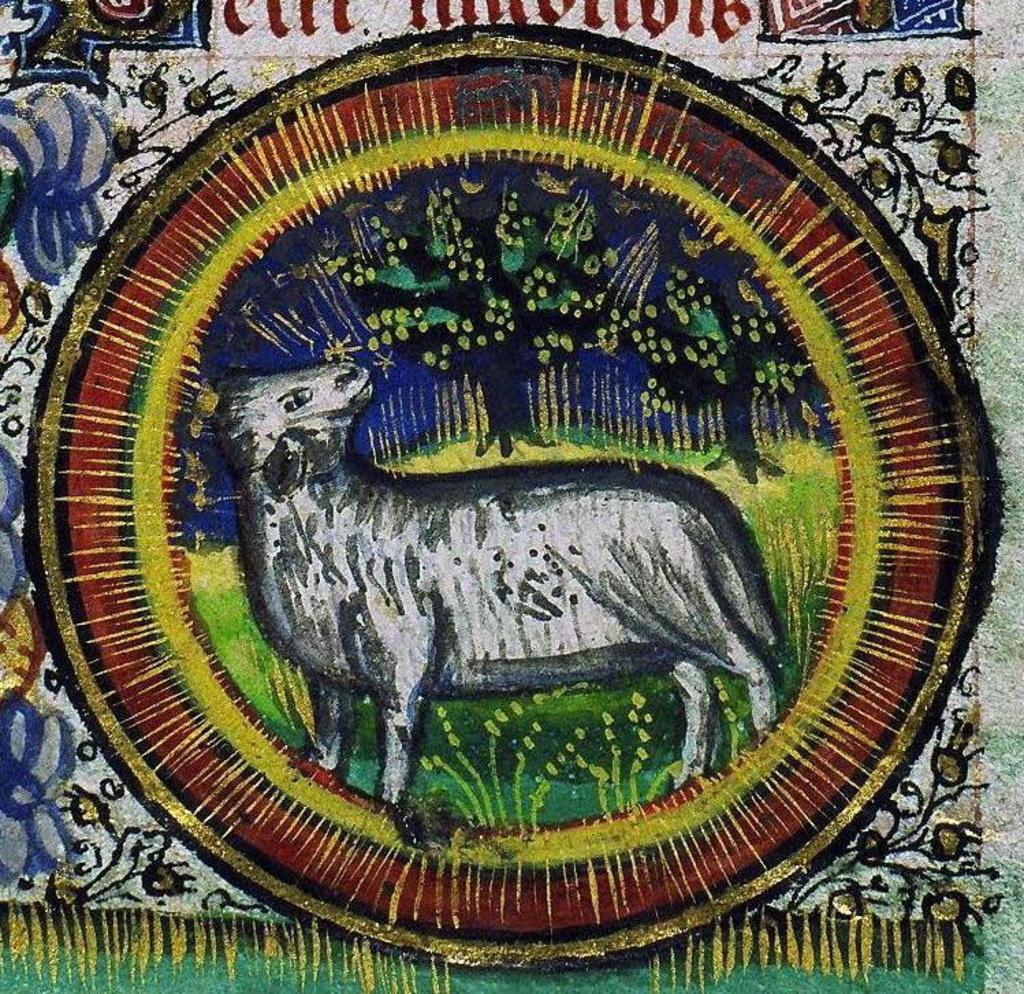What is the main subject of the image? There is a painting in the image. What can be seen in the painting? The painting contains an animal, grass, and a tree. What type of pest can be seen crawling on the dolls in the image? There are no dolls or pests present in the image; it features a painting with an animal, grass, and a tree. 